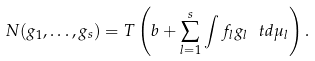Convert formula to latex. <formula><loc_0><loc_0><loc_500><loc_500>N ( g _ { 1 } , \dots , g _ { s } ) = T \left ( b + \sum _ { l = 1 } ^ { s } \int f _ { l } g _ { l } \, \ t d \mu _ { l } \right ) .</formula> 